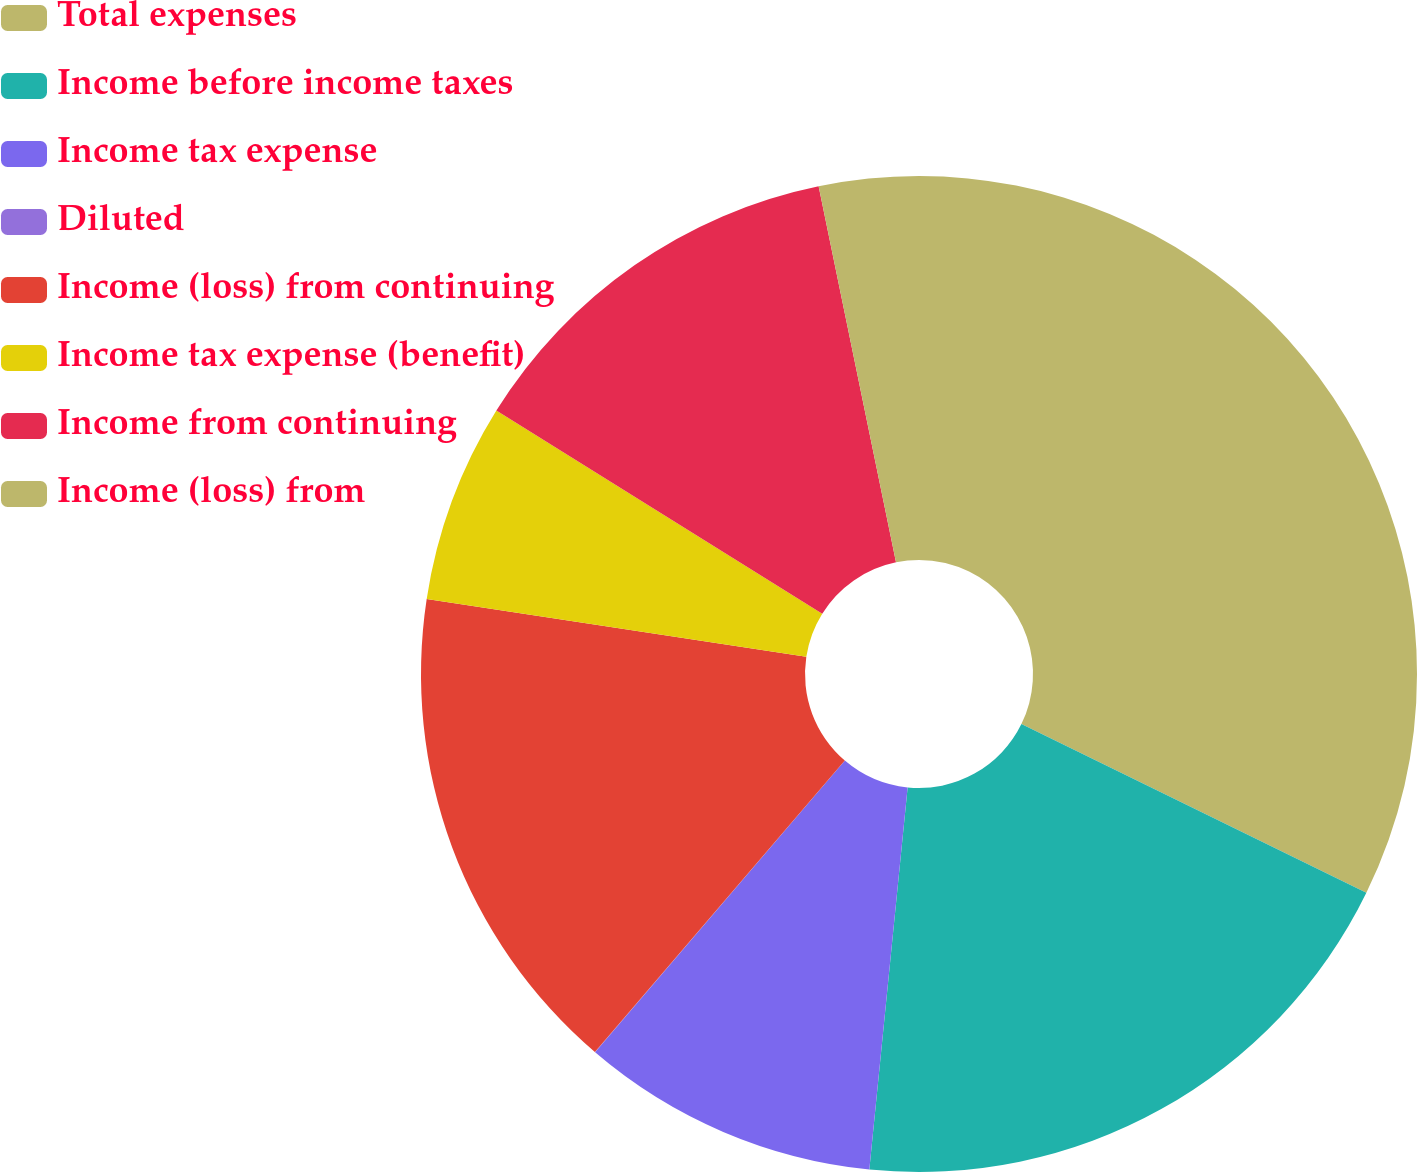Convert chart to OTSL. <chart><loc_0><loc_0><loc_500><loc_500><pie_chart><fcel>Total expenses<fcel>Income before income taxes<fcel>Income tax expense<fcel>Diluted<fcel>Income (loss) from continuing<fcel>Income tax expense (benefit)<fcel>Income from continuing<fcel>Income (loss) from<nl><fcel>32.24%<fcel>19.35%<fcel>9.68%<fcel>0.01%<fcel>16.13%<fcel>6.46%<fcel>12.9%<fcel>3.23%<nl></chart> 